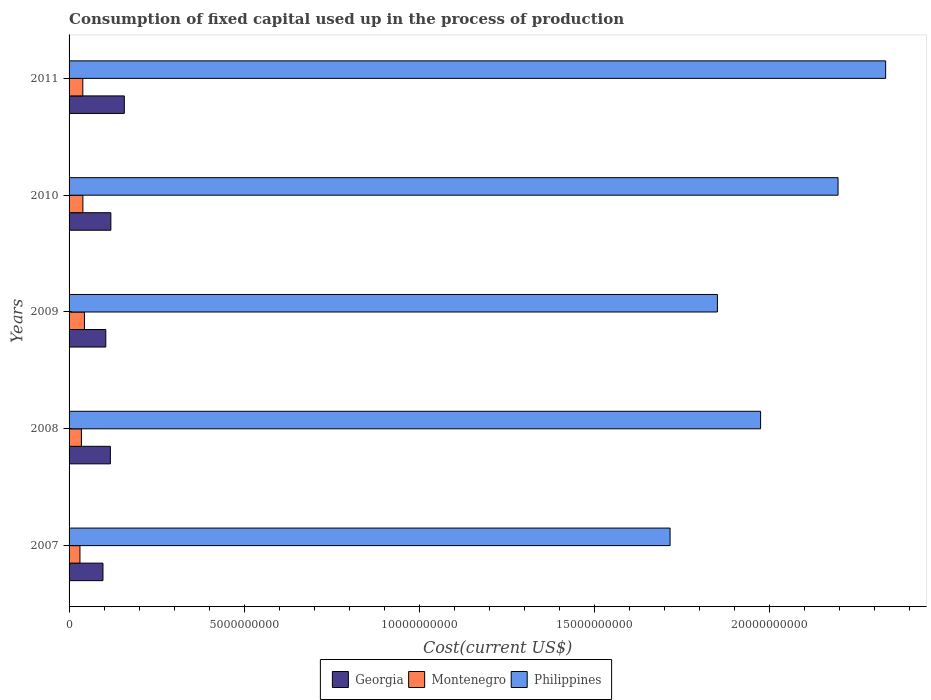How many different coloured bars are there?
Provide a short and direct response. 3. How many bars are there on the 4th tick from the top?
Provide a short and direct response. 3. What is the label of the 5th group of bars from the top?
Your answer should be very brief. 2007. What is the amount consumed in the process of production in Montenegro in 2010?
Your answer should be very brief. 3.95e+08. Across all years, what is the maximum amount consumed in the process of production in Philippines?
Provide a short and direct response. 2.33e+1. Across all years, what is the minimum amount consumed in the process of production in Montenegro?
Give a very brief answer. 3.11e+08. In which year was the amount consumed in the process of production in Philippines maximum?
Give a very brief answer. 2011. What is the total amount consumed in the process of production in Georgia in the graph?
Keep it short and to the point. 5.97e+09. What is the difference between the amount consumed in the process of production in Montenegro in 2007 and that in 2009?
Provide a short and direct response. -1.28e+08. What is the difference between the amount consumed in the process of production in Philippines in 2010 and the amount consumed in the process of production in Georgia in 2011?
Offer a terse response. 2.04e+1. What is the average amount consumed in the process of production in Georgia per year?
Provide a succinct answer. 1.19e+09. In the year 2009, what is the difference between the amount consumed in the process of production in Montenegro and amount consumed in the process of production in Georgia?
Offer a terse response. -6.10e+08. What is the ratio of the amount consumed in the process of production in Montenegro in 2008 to that in 2009?
Your response must be concise. 0.8. Is the difference between the amount consumed in the process of production in Montenegro in 2010 and 2011 greater than the difference between the amount consumed in the process of production in Georgia in 2010 and 2011?
Offer a very short reply. Yes. What is the difference between the highest and the second highest amount consumed in the process of production in Georgia?
Your answer should be very brief. 3.84e+08. What is the difference between the highest and the lowest amount consumed in the process of production in Philippines?
Offer a very short reply. 6.16e+09. What does the 2nd bar from the top in 2008 represents?
Your answer should be very brief. Montenegro. What does the 2nd bar from the bottom in 2010 represents?
Ensure brevity in your answer.  Montenegro. Is it the case that in every year, the sum of the amount consumed in the process of production in Philippines and amount consumed in the process of production in Georgia is greater than the amount consumed in the process of production in Montenegro?
Your answer should be compact. Yes. How many bars are there?
Provide a succinct answer. 15. Are all the bars in the graph horizontal?
Provide a short and direct response. Yes. How many years are there in the graph?
Ensure brevity in your answer.  5. What is the difference between two consecutive major ticks on the X-axis?
Ensure brevity in your answer.  5.00e+09. Does the graph contain any zero values?
Keep it short and to the point. No. Does the graph contain grids?
Your response must be concise. No. Where does the legend appear in the graph?
Ensure brevity in your answer.  Bottom center. How are the legend labels stacked?
Provide a short and direct response. Horizontal. What is the title of the graph?
Ensure brevity in your answer.  Consumption of fixed capital used up in the process of production. What is the label or title of the X-axis?
Offer a terse response. Cost(current US$). What is the label or title of the Y-axis?
Your answer should be compact. Years. What is the Cost(current US$) of Georgia in 2007?
Offer a very short reply. 9.68e+08. What is the Cost(current US$) in Montenegro in 2007?
Keep it short and to the point. 3.11e+08. What is the Cost(current US$) in Philippines in 2007?
Your answer should be very brief. 1.72e+1. What is the Cost(current US$) of Georgia in 2008?
Offer a very short reply. 1.18e+09. What is the Cost(current US$) in Montenegro in 2008?
Give a very brief answer. 3.52e+08. What is the Cost(current US$) in Philippines in 2008?
Your response must be concise. 1.97e+1. What is the Cost(current US$) of Georgia in 2009?
Your answer should be compact. 1.05e+09. What is the Cost(current US$) of Montenegro in 2009?
Provide a short and direct response. 4.39e+08. What is the Cost(current US$) in Philippines in 2009?
Offer a terse response. 1.85e+1. What is the Cost(current US$) in Georgia in 2010?
Keep it short and to the point. 1.19e+09. What is the Cost(current US$) of Montenegro in 2010?
Your answer should be very brief. 3.95e+08. What is the Cost(current US$) in Philippines in 2010?
Provide a succinct answer. 2.20e+1. What is the Cost(current US$) of Georgia in 2011?
Offer a terse response. 1.58e+09. What is the Cost(current US$) of Montenegro in 2011?
Offer a terse response. 3.92e+08. What is the Cost(current US$) of Philippines in 2011?
Your response must be concise. 2.33e+1. Across all years, what is the maximum Cost(current US$) in Georgia?
Make the answer very short. 1.58e+09. Across all years, what is the maximum Cost(current US$) of Montenegro?
Your answer should be very brief. 4.39e+08. Across all years, what is the maximum Cost(current US$) in Philippines?
Keep it short and to the point. 2.33e+1. Across all years, what is the minimum Cost(current US$) of Georgia?
Keep it short and to the point. 9.68e+08. Across all years, what is the minimum Cost(current US$) in Montenegro?
Your response must be concise. 3.11e+08. Across all years, what is the minimum Cost(current US$) of Philippines?
Give a very brief answer. 1.72e+1. What is the total Cost(current US$) of Georgia in the graph?
Give a very brief answer. 5.97e+09. What is the total Cost(current US$) of Montenegro in the graph?
Offer a terse response. 1.89e+09. What is the total Cost(current US$) of Philippines in the graph?
Offer a terse response. 1.01e+11. What is the difference between the Cost(current US$) of Georgia in 2007 and that in 2008?
Keep it short and to the point. -2.11e+08. What is the difference between the Cost(current US$) in Montenegro in 2007 and that in 2008?
Offer a very short reply. -4.14e+07. What is the difference between the Cost(current US$) of Philippines in 2007 and that in 2008?
Ensure brevity in your answer.  -2.58e+09. What is the difference between the Cost(current US$) of Georgia in 2007 and that in 2009?
Offer a terse response. -8.04e+07. What is the difference between the Cost(current US$) of Montenegro in 2007 and that in 2009?
Your answer should be compact. -1.28e+08. What is the difference between the Cost(current US$) of Philippines in 2007 and that in 2009?
Your response must be concise. -1.35e+09. What is the difference between the Cost(current US$) in Georgia in 2007 and that in 2010?
Give a very brief answer. -2.25e+08. What is the difference between the Cost(current US$) of Montenegro in 2007 and that in 2010?
Your response must be concise. -8.37e+07. What is the difference between the Cost(current US$) of Philippines in 2007 and that in 2010?
Offer a very short reply. -4.80e+09. What is the difference between the Cost(current US$) in Georgia in 2007 and that in 2011?
Your answer should be very brief. -6.10e+08. What is the difference between the Cost(current US$) in Montenegro in 2007 and that in 2011?
Ensure brevity in your answer.  -8.14e+07. What is the difference between the Cost(current US$) in Philippines in 2007 and that in 2011?
Offer a terse response. -6.16e+09. What is the difference between the Cost(current US$) in Georgia in 2008 and that in 2009?
Offer a terse response. 1.31e+08. What is the difference between the Cost(current US$) in Montenegro in 2008 and that in 2009?
Your response must be concise. -8.67e+07. What is the difference between the Cost(current US$) of Philippines in 2008 and that in 2009?
Make the answer very short. 1.23e+09. What is the difference between the Cost(current US$) of Georgia in 2008 and that in 2010?
Your answer should be very brief. -1.40e+07. What is the difference between the Cost(current US$) of Montenegro in 2008 and that in 2010?
Your response must be concise. -4.24e+07. What is the difference between the Cost(current US$) of Philippines in 2008 and that in 2010?
Your response must be concise. -2.21e+09. What is the difference between the Cost(current US$) in Georgia in 2008 and that in 2011?
Give a very brief answer. -3.98e+08. What is the difference between the Cost(current US$) of Montenegro in 2008 and that in 2011?
Provide a short and direct response. -4.00e+07. What is the difference between the Cost(current US$) in Philippines in 2008 and that in 2011?
Offer a terse response. -3.57e+09. What is the difference between the Cost(current US$) of Georgia in 2009 and that in 2010?
Provide a short and direct response. -1.45e+08. What is the difference between the Cost(current US$) in Montenegro in 2009 and that in 2010?
Provide a short and direct response. 4.43e+07. What is the difference between the Cost(current US$) of Philippines in 2009 and that in 2010?
Your answer should be compact. -3.44e+09. What is the difference between the Cost(current US$) in Georgia in 2009 and that in 2011?
Your answer should be very brief. -5.29e+08. What is the difference between the Cost(current US$) of Montenegro in 2009 and that in 2011?
Offer a terse response. 4.67e+07. What is the difference between the Cost(current US$) in Philippines in 2009 and that in 2011?
Offer a very short reply. -4.80e+09. What is the difference between the Cost(current US$) in Georgia in 2010 and that in 2011?
Give a very brief answer. -3.84e+08. What is the difference between the Cost(current US$) in Montenegro in 2010 and that in 2011?
Offer a terse response. 2.32e+06. What is the difference between the Cost(current US$) of Philippines in 2010 and that in 2011?
Your answer should be very brief. -1.36e+09. What is the difference between the Cost(current US$) in Georgia in 2007 and the Cost(current US$) in Montenegro in 2008?
Provide a succinct answer. 6.16e+08. What is the difference between the Cost(current US$) of Georgia in 2007 and the Cost(current US$) of Philippines in 2008?
Offer a terse response. -1.88e+1. What is the difference between the Cost(current US$) of Montenegro in 2007 and the Cost(current US$) of Philippines in 2008?
Your response must be concise. -1.94e+1. What is the difference between the Cost(current US$) of Georgia in 2007 and the Cost(current US$) of Montenegro in 2009?
Make the answer very short. 5.29e+08. What is the difference between the Cost(current US$) in Georgia in 2007 and the Cost(current US$) in Philippines in 2009?
Offer a terse response. -1.75e+1. What is the difference between the Cost(current US$) in Montenegro in 2007 and the Cost(current US$) in Philippines in 2009?
Give a very brief answer. -1.82e+1. What is the difference between the Cost(current US$) of Georgia in 2007 and the Cost(current US$) of Montenegro in 2010?
Your answer should be compact. 5.73e+08. What is the difference between the Cost(current US$) in Georgia in 2007 and the Cost(current US$) in Philippines in 2010?
Your response must be concise. -2.10e+1. What is the difference between the Cost(current US$) of Montenegro in 2007 and the Cost(current US$) of Philippines in 2010?
Offer a very short reply. -2.16e+1. What is the difference between the Cost(current US$) in Georgia in 2007 and the Cost(current US$) in Montenegro in 2011?
Give a very brief answer. 5.76e+08. What is the difference between the Cost(current US$) of Georgia in 2007 and the Cost(current US$) of Philippines in 2011?
Offer a very short reply. -2.23e+1. What is the difference between the Cost(current US$) in Montenegro in 2007 and the Cost(current US$) in Philippines in 2011?
Make the answer very short. -2.30e+1. What is the difference between the Cost(current US$) of Georgia in 2008 and the Cost(current US$) of Montenegro in 2009?
Make the answer very short. 7.40e+08. What is the difference between the Cost(current US$) in Georgia in 2008 and the Cost(current US$) in Philippines in 2009?
Offer a terse response. -1.73e+1. What is the difference between the Cost(current US$) in Montenegro in 2008 and the Cost(current US$) in Philippines in 2009?
Your answer should be compact. -1.82e+1. What is the difference between the Cost(current US$) of Georgia in 2008 and the Cost(current US$) of Montenegro in 2010?
Your response must be concise. 7.85e+08. What is the difference between the Cost(current US$) of Georgia in 2008 and the Cost(current US$) of Philippines in 2010?
Your answer should be very brief. -2.08e+1. What is the difference between the Cost(current US$) of Montenegro in 2008 and the Cost(current US$) of Philippines in 2010?
Give a very brief answer. -2.16e+1. What is the difference between the Cost(current US$) in Georgia in 2008 and the Cost(current US$) in Montenegro in 2011?
Provide a succinct answer. 7.87e+08. What is the difference between the Cost(current US$) of Georgia in 2008 and the Cost(current US$) of Philippines in 2011?
Offer a very short reply. -2.21e+1. What is the difference between the Cost(current US$) in Montenegro in 2008 and the Cost(current US$) in Philippines in 2011?
Offer a terse response. -2.30e+1. What is the difference between the Cost(current US$) in Georgia in 2009 and the Cost(current US$) in Montenegro in 2010?
Your answer should be very brief. 6.54e+08. What is the difference between the Cost(current US$) of Georgia in 2009 and the Cost(current US$) of Philippines in 2010?
Offer a terse response. -2.09e+1. What is the difference between the Cost(current US$) of Montenegro in 2009 and the Cost(current US$) of Philippines in 2010?
Your response must be concise. -2.15e+1. What is the difference between the Cost(current US$) of Georgia in 2009 and the Cost(current US$) of Montenegro in 2011?
Keep it short and to the point. 6.56e+08. What is the difference between the Cost(current US$) of Georgia in 2009 and the Cost(current US$) of Philippines in 2011?
Offer a very short reply. -2.23e+1. What is the difference between the Cost(current US$) in Montenegro in 2009 and the Cost(current US$) in Philippines in 2011?
Provide a succinct answer. -2.29e+1. What is the difference between the Cost(current US$) in Georgia in 2010 and the Cost(current US$) in Montenegro in 2011?
Keep it short and to the point. 8.01e+08. What is the difference between the Cost(current US$) in Georgia in 2010 and the Cost(current US$) in Philippines in 2011?
Make the answer very short. -2.21e+1. What is the difference between the Cost(current US$) in Montenegro in 2010 and the Cost(current US$) in Philippines in 2011?
Make the answer very short. -2.29e+1. What is the average Cost(current US$) in Georgia per year?
Offer a very short reply. 1.19e+09. What is the average Cost(current US$) of Montenegro per year?
Give a very brief answer. 3.78e+08. What is the average Cost(current US$) of Philippines per year?
Provide a succinct answer. 2.01e+1. In the year 2007, what is the difference between the Cost(current US$) in Georgia and Cost(current US$) in Montenegro?
Your response must be concise. 6.57e+08. In the year 2007, what is the difference between the Cost(current US$) of Georgia and Cost(current US$) of Philippines?
Provide a short and direct response. -1.62e+1. In the year 2007, what is the difference between the Cost(current US$) of Montenegro and Cost(current US$) of Philippines?
Provide a short and direct response. -1.68e+1. In the year 2008, what is the difference between the Cost(current US$) in Georgia and Cost(current US$) in Montenegro?
Make the answer very short. 8.27e+08. In the year 2008, what is the difference between the Cost(current US$) of Georgia and Cost(current US$) of Philippines?
Give a very brief answer. -1.86e+1. In the year 2008, what is the difference between the Cost(current US$) of Montenegro and Cost(current US$) of Philippines?
Make the answer very short. -1.94e+1. In the year 2009, what is the difference between the Cost(current US$) of Georgia and Cost(current US$) of Montenegro?
Offer a very short reply. 6.10e+08. In the year 2009, what is the difference between the Cost(current US$) of Georgia and Cost(current US$) of Philippines?
Give a very brief answer. -1.75e+1. In the year 2009, what is the difference between the Cost(current US$) in Montenegro and Cost(current US$) in Philippines?
Give a very brief answer. -1.81e+1. In the year 2010, what is the difference between the Cost(current US$) of Georgia and Cost(current US$) of Montenegro?
Your answer should be compact. 7.99e+08. In the year 2010, what is the difference between the Cost(current US$) of Georgia and Cost(current US$) of Philippines?
Your answer should be compact. -2.08e+1. In the year 2010, what is the difference between the Cost(current US$) in Montenegro and Cost(current US$) in Philippines?
Provide a short and direct response. -2.16e+1. In the year 2011, what is the difference between the Cost(current US$) in Georgia and Cost(current US$) in Montenegro?
Offer a terse response. 1.19e+09. In the year 2011, what is the difference between the Cost(current US$) in Georgia and Cost(current US$) in Philippines?
Make the answer very short. -2.17e+1. In the year 2011, what is the difference between the Cost(current US$) of Montenegro and Cost(current US$) of Philippines?
Offer a terse response. -2.29e+1. What is the ratio of the Cost(current US$) of Georgia in 2007 to that in 2008?
Provide a short and direct response. 0.82. What is the ratio of the Cost(current US$) of Montenegro in 2007 to that in 2008?
Keep it short and to the point. 0.88. What is the ratio of the Cost(current US$) in Philippines in 2007 to that in 2008?
Provide a succinct answer. 0.87. What is the ratio of the Cost(current US$) in Georgia in 2007 to that in 2009?
Your answer should be compact. 0.92. What is the ratio of the Cost(current US$) of Montenegro in 2007 to that in 2009?
Your answer should be very brief. 0.71. What is the ratio of the Cost(current US$) in Philippines in 2007 to that in 2009?
Keep it short and to the point. 0.93. What is the ratio of the Cost(current US$) in Georgia in 2007 to that in 2010?
Offer a terse response. 0.81. What is the ratio of the Cost(current US$) in Montenegro in 2007 to that in 2010?
Provide a short and direct response. 0.79. What is the ratio of the Cost(current US$) in Philippines in 2007 to that in 2010?
Ensure brevity in your answer.  0.78. What is the ratio of the Cost(current US$) of Georgia in 2007 to that in 2011?
Give a very brief answer. 0.61. What is the ratio of the Cost(current US$) of Montenegro in 2007 to that in 2011?
Offer a terse response. 0.79. What is the ratio of the Cost(current US$) in Philippines in 2007 to that in 2011?
Ensure brevity in your answer.  0.74. What is the ratio of the Cost(current US$) of Georgia in 2008 to that in 2009?
Provide a succinct answer. 1.12. What is the ratio of the Cost(current US$) in Montenegro in 2008 to that in 2009?
Make the answer very short. 0.8. What is the ratio of the Cost(current US$) in Philippines in 2008 to that in 2009?
Offer a terse response. 1.07. What is the ratio of the Cost(current US$) of Georgia in 2008 to that in 2010?
Provide a succinct answer. 0.99. What is the ratio of the Cost(current US$) of Montenegro in 2008 to that in 2010?
Offer a terse response. 0.89. What is the ratio of the Cost(current US$) in Philippines in 2008 to that in 2010?
Offer a terse response. 0.9. What is the ratio of the Cost(current US$) of Georgia in 2008 to that in 2011?
Keep it short and to the point. 0.75. What is the ratio of the Cost(current US$) in Montenegro in 2008 to that in 2011?
Offer a very short reply. 0.9. What is the ratio of the Cost(current US$) of Philippines in 2008 to that in 2011?
Your response must be concise. 0.85. What is the ratio of the Cost(current US$) in Georgia in 2009 to that in 2010?
Keep it short and to the point. 0.88. What is the ratio of the Cost(current US$) of Montenegro in 2009 to that in 2010?
Your answer should be very brief. 1.11. What is the ratio of the Cost(current US$) in Philippines in 2009 to that in 2010?
Your answer should be very brief. 0.84. What is the ratio of the Cost(current US$) in Georgia in 2009 to that in 2011?
Make the answer very short. 0.66. What is the ratio of the Cost(current US$) of Montenegro in 2009 to that in 2011?
Your response must be concise. 1.12. What is the ratio of the Cost(current US$) of Philippines in 2009 to that in 2011?
Keep it short and to the point. 0.79. What is the ratio of the Cost(current US$) in Georgia in 2010 to that in 2011?
Your response must be concise. 0.76. What is the ratio of the Cost(current US$) of Montenegro in 2010 to that in 2011?
Provide a short and direct response. 1.01. What is the ratio of the Cost(current US$) of Philippines in 2010 to that in 2011?
Offer a very short reply. 0.94. What is the difference between the highest and the second highest Cost(current US$) in Georgia?
Offer a very short reply. 3.84e+08. What is the difference between the highest and the second highest Cost(current US$) in Montenegro?
Your answer should be very brief. 4.43e+07. What is the difference between the highest and the second highest Cost(current US$) of Philippines?
Offer a very short reply. 1.36e+09. What is the difference between the highest and the lowest Cost(current US$) of Georgia?
Offer a very short reply. 6.10e+08. What is the difference between the highest and the lowest Cost(current US$) in Montenegro?
Provide a short and direct response. 1.28e+08. What is the difference between the highest and the lowest Cost(current US$) in Philippines?
Your answer should be very brief. 6.16e+09. 